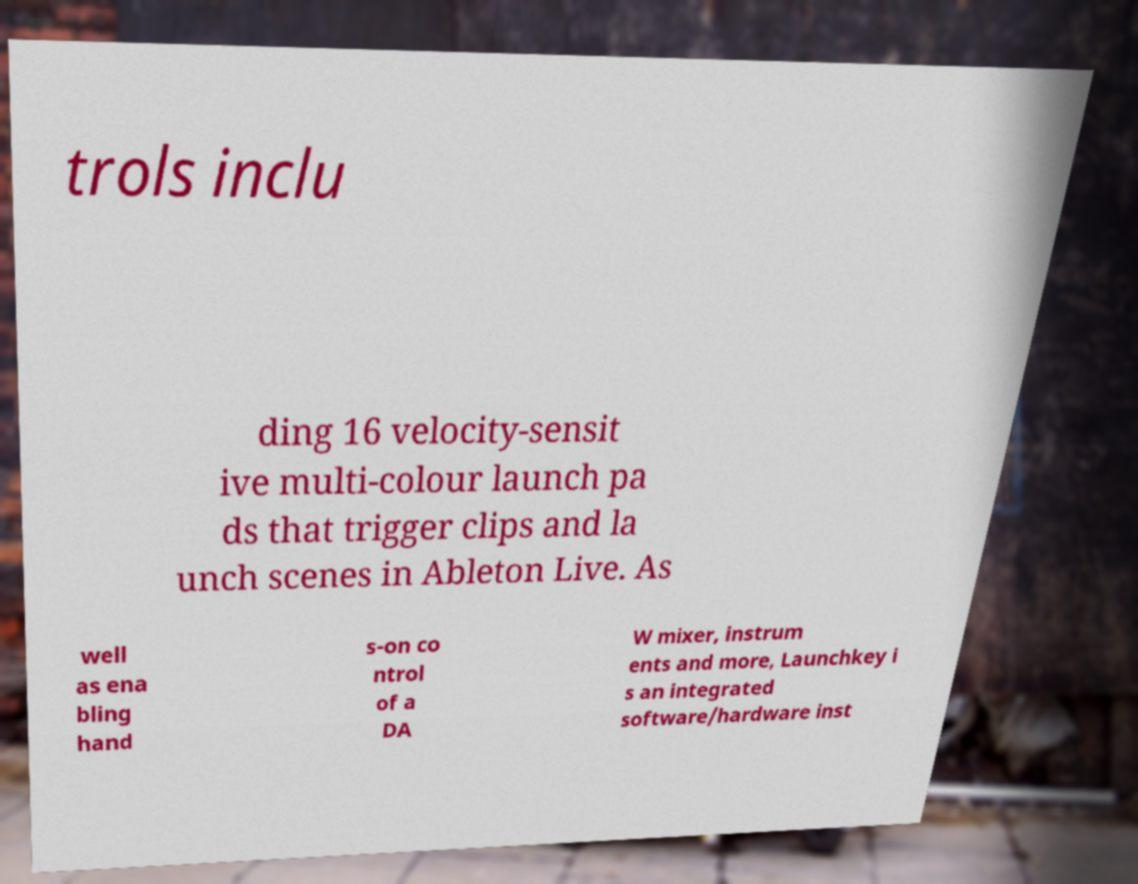There's text embedded in this image that I need extracted. Can you transcribe it verbatim? trols inclu ding 16 velocity-sensit ive multi-colour launch pa ds that trigger clips and la unch scenes in Ableton Live. As well as ena bling hand s-on co ntrol of a DA W mixer, instrum ents and more, Launchkey i s an integrated software/hardware inst 